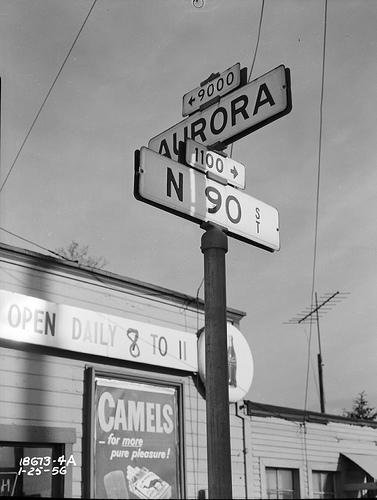Is this a black and white photo?
Short answer required. Yes. What are the hours for the business in the background?
Quick response, please. 8 to 11. What type of building is that?
Give a very brief answer. Store. What numbers are posted on the sign?
Keep it brief. 90. What block is the street. sign on?
Write a very short answer. Aurora. Whose cleaners is it?
Answer briefly. Camels. Is the store open?
Give a very brief answer. Yes. What is the name of the drive?
Write a very short answer. Aurora. How many signs do you see?
Be succinct. 6. 